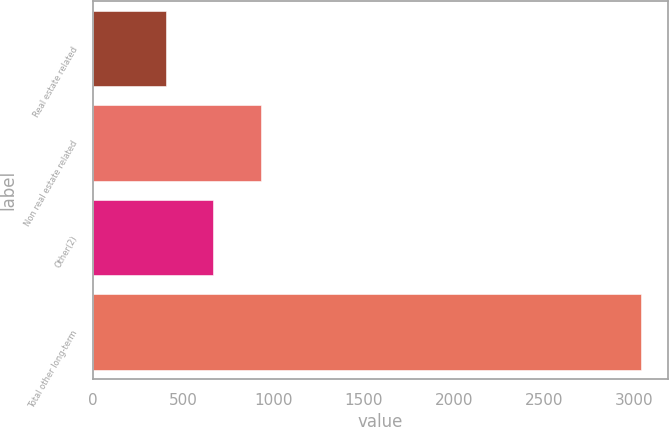<chart> <loc_0><loc_0><loc_500><loc_500><bar_chart><fcel>Real estate related<fcel>Non real estate related<fcel>Other(2)<fcel>Total other long-term<nl><fcel>405<fcel>931<fcel>668<fcel>3035<nl></chart> 